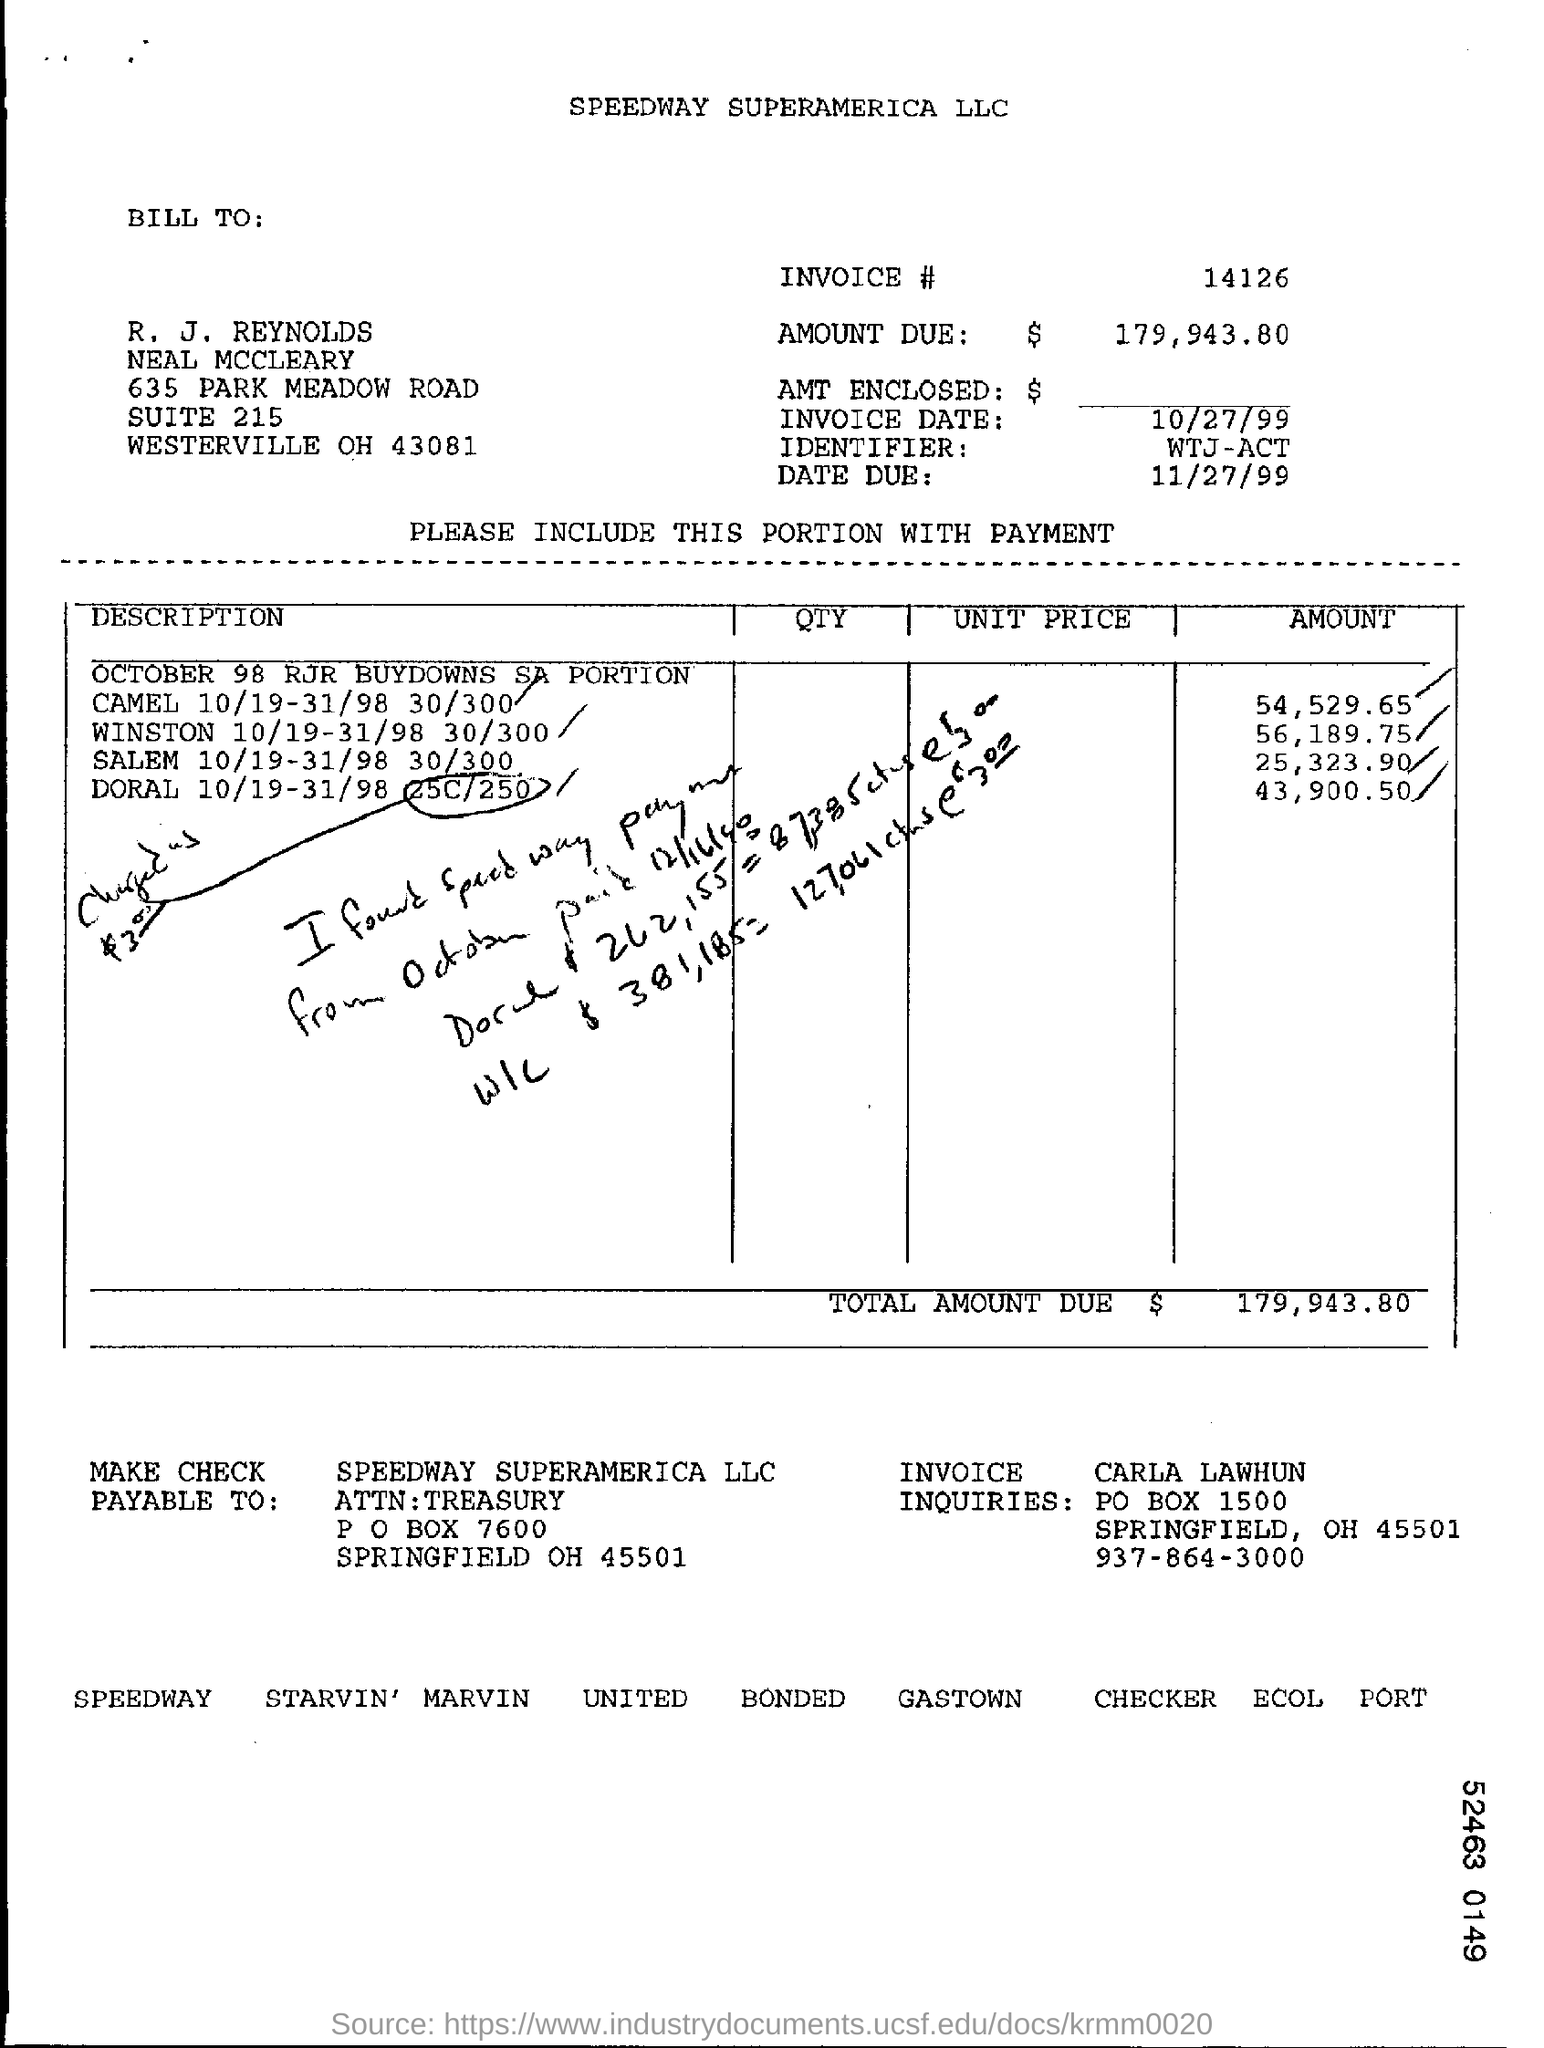What is the INVOICE #?
Offer a very short reply. 14126. Which is the DUE DATE?
Offer a terse response. 11/27/99. Which is the city in the Billing address?
Ensure brevity in your answer.  WESTERVILLE. What is the amount for WINSTON 10/19-31/98 30/300?
Your answer should be compact. $56,189.75. Which is the city in the PAY TO Address?
Make the answer very short. SPRINGFIELD. 